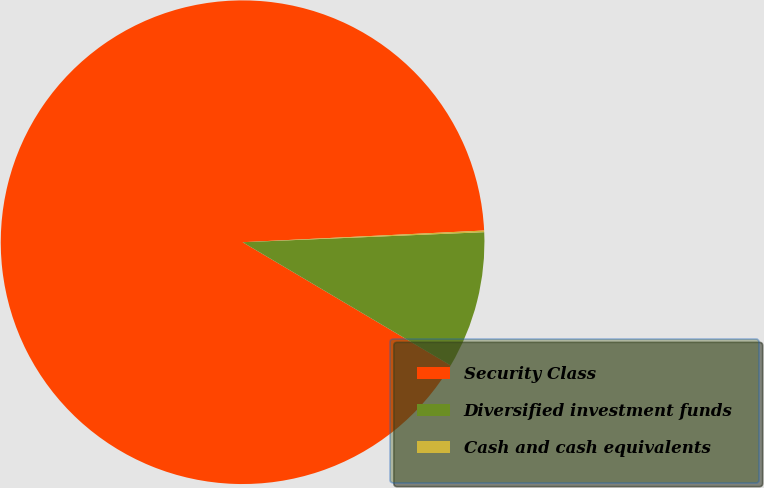Convert chart to OTSL. <chart><loc_0><loc_0><loc_500><loc_500><pie_chart><fcel>Security Class<fcel>Diversified investment funds<fcel>Cash and cash equivalents<nl><fcel>90.71%<fcel>9.17%<fcel>0.11%<nl></chart> 